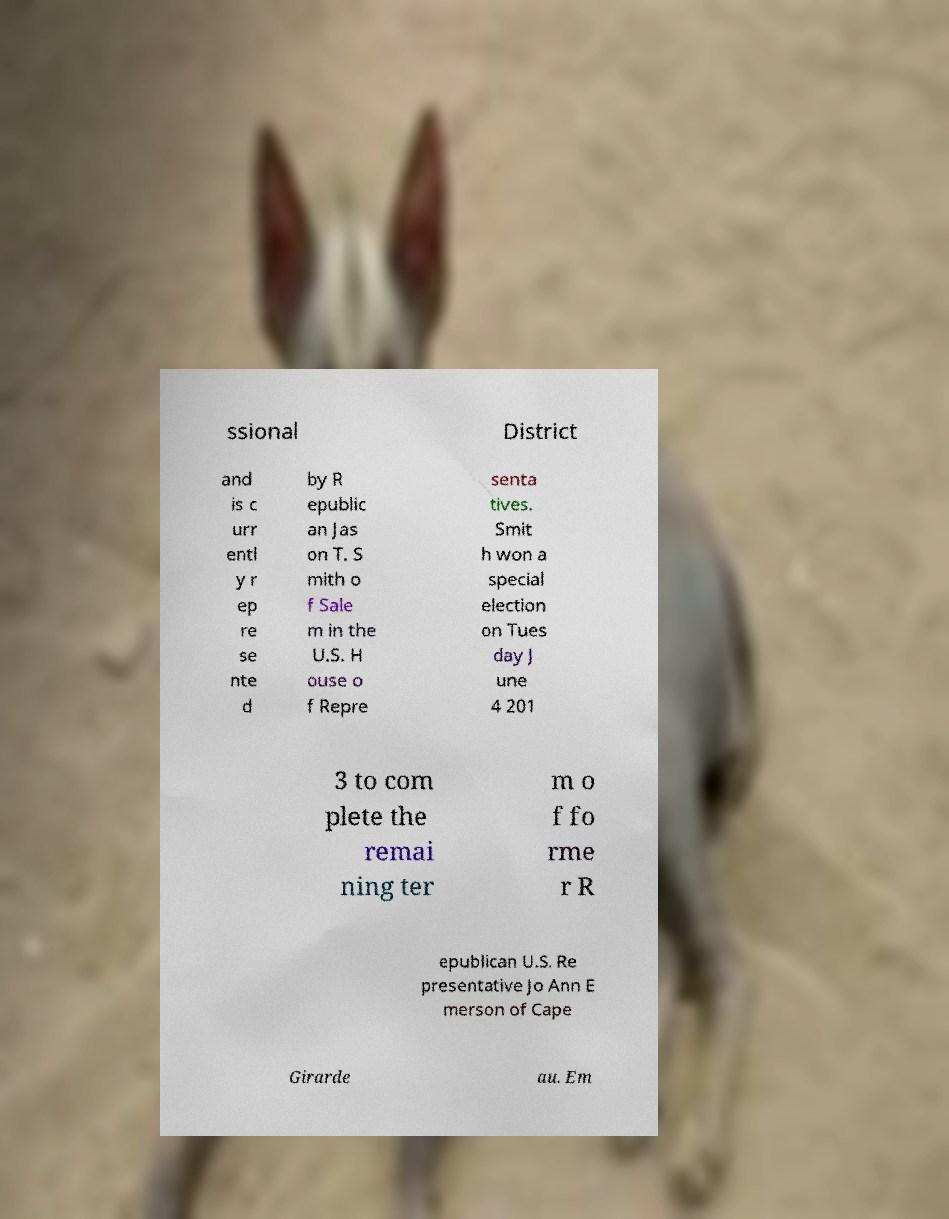Can you accurately transcribe the text from the provided image for me? ssional District and is c urr entl y r ep re se nte d by R epublic an Jas on T. S mith o f Sale m in the U.S. H ouse o f Repre senta tives. Smit h won a special election on Tues day J une 4 201 3 to com plete the remai ning ter m o f fo rme r R epublican U.S. Re presentative Jo Ann E merson of Cape Girarde au. Em 